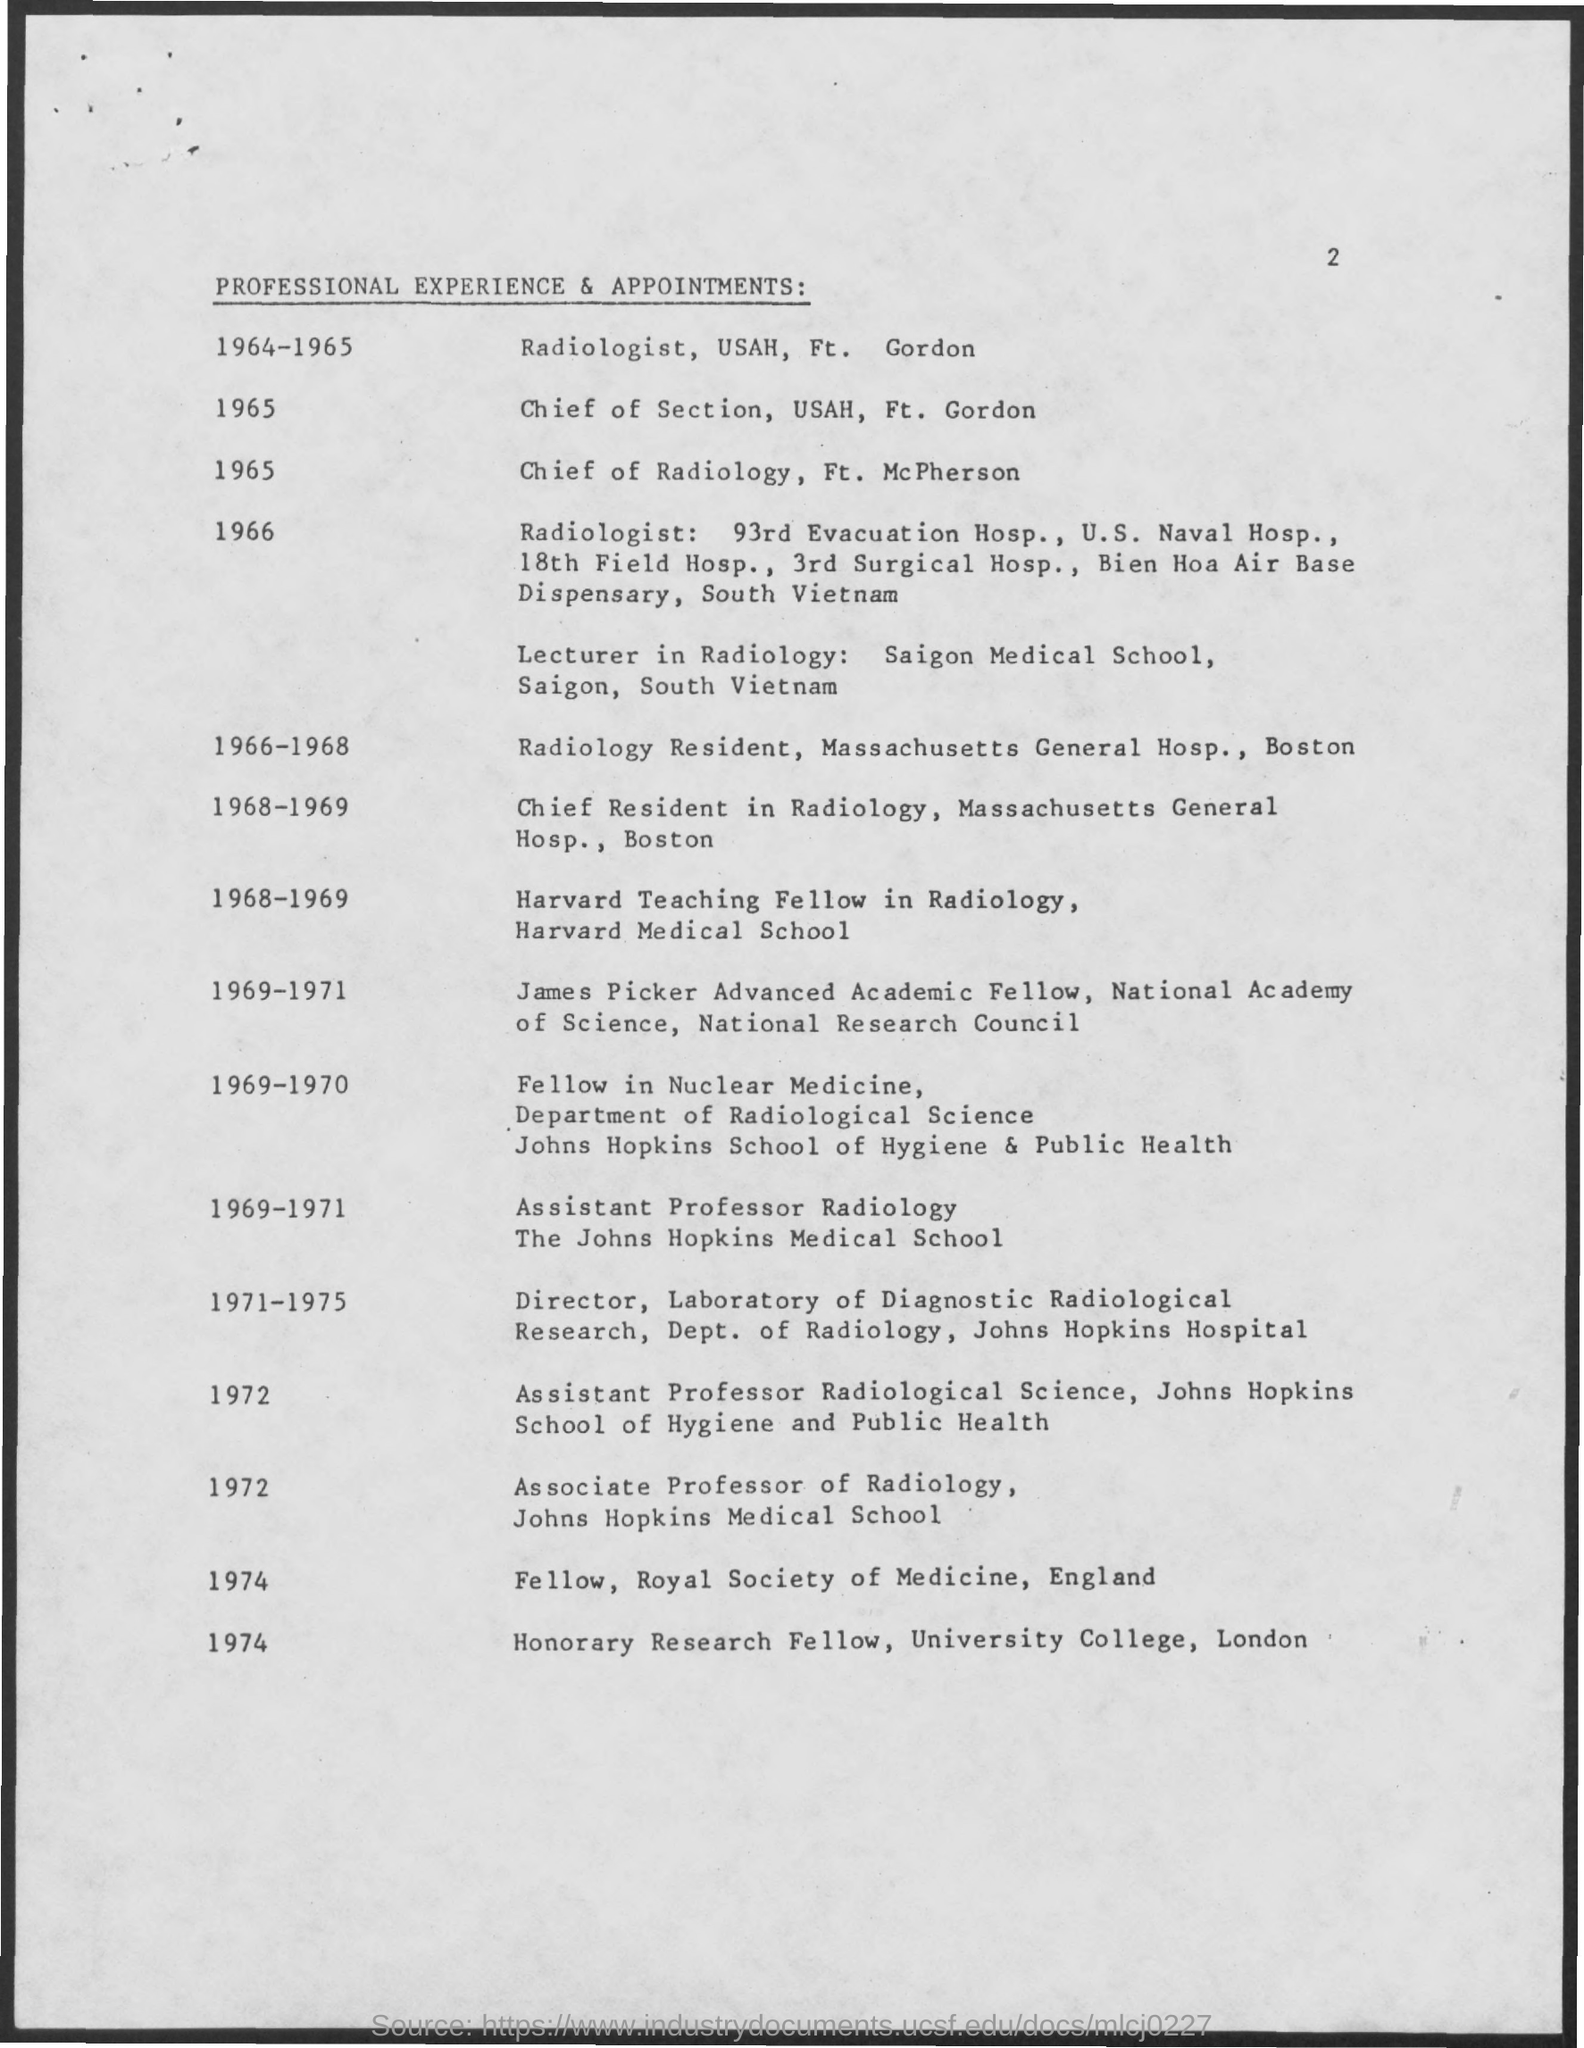What is the Page Number?
Provide a succinct answer. 2. What is the title of the document?
Your answer should be compact. PROFESSIONAL EXPERIENCE & APPOINTMENTS. Who is the Chief of Radiology in 1965?
Your response must be concise. FT. MCPHERSON. Who is the Chief of Section in 1965?
Make the answer very short. USAH, Ft. Gordon. 